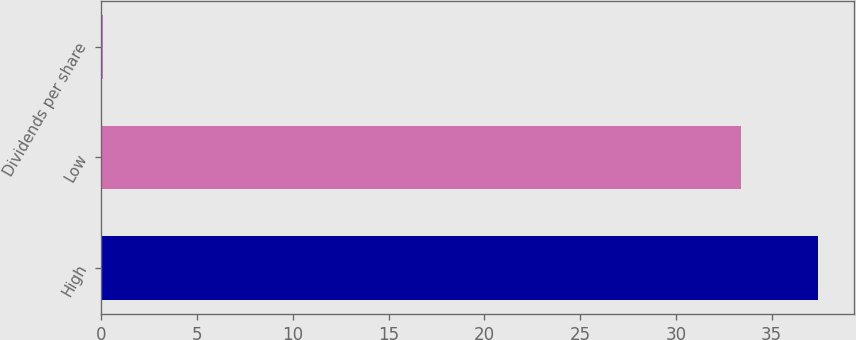Convert chart to OTSL. <chart><loc_0><loc_0><loc_500><loc_500><bar_chart><fcel>High<fcel>Low<fcel>Dividends per share<nl><fcel>37.43<fcel>33.41<fcel>0.07<nl></chart> 